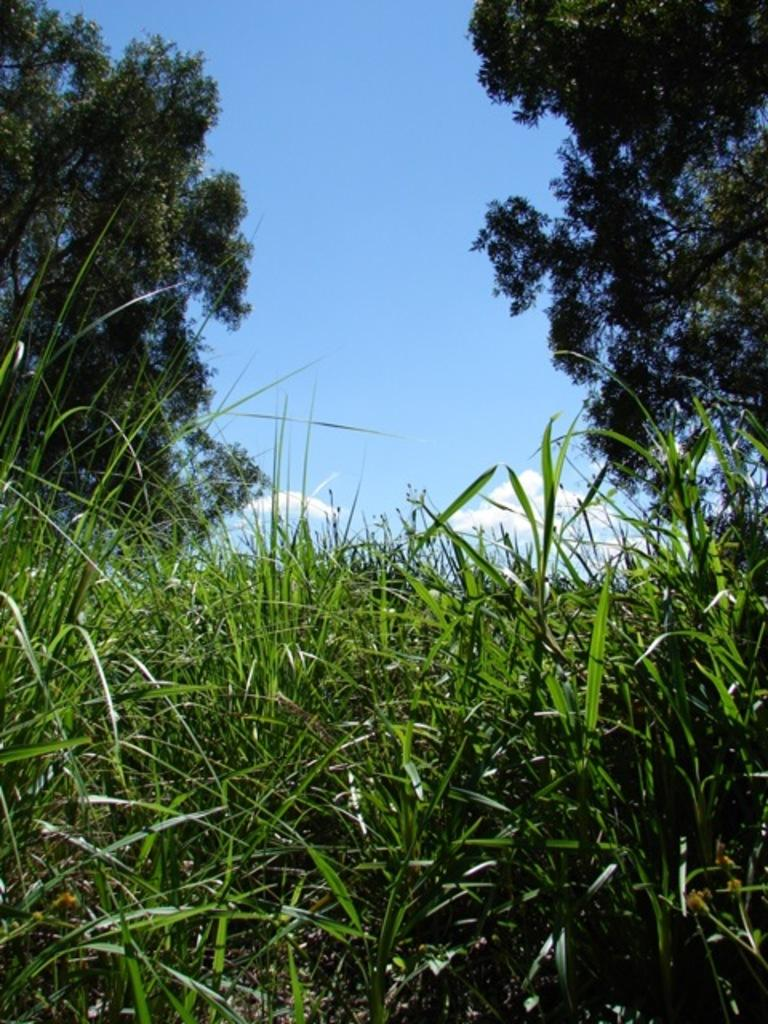What type of vegetation is at the bottom of the image? There is grass at the bottom of the image. What can be seen in the background of the image? There are trees in the background of the image. What is visible at the top of the image? The sky is visible at the top of the image. What is present in the sky? Clouds are present in the sky. What type of lettuce is being used in the fight depicted in the image? There is no fight or lettuce present in the image; it features grass, trees, and clouds in the sky. 